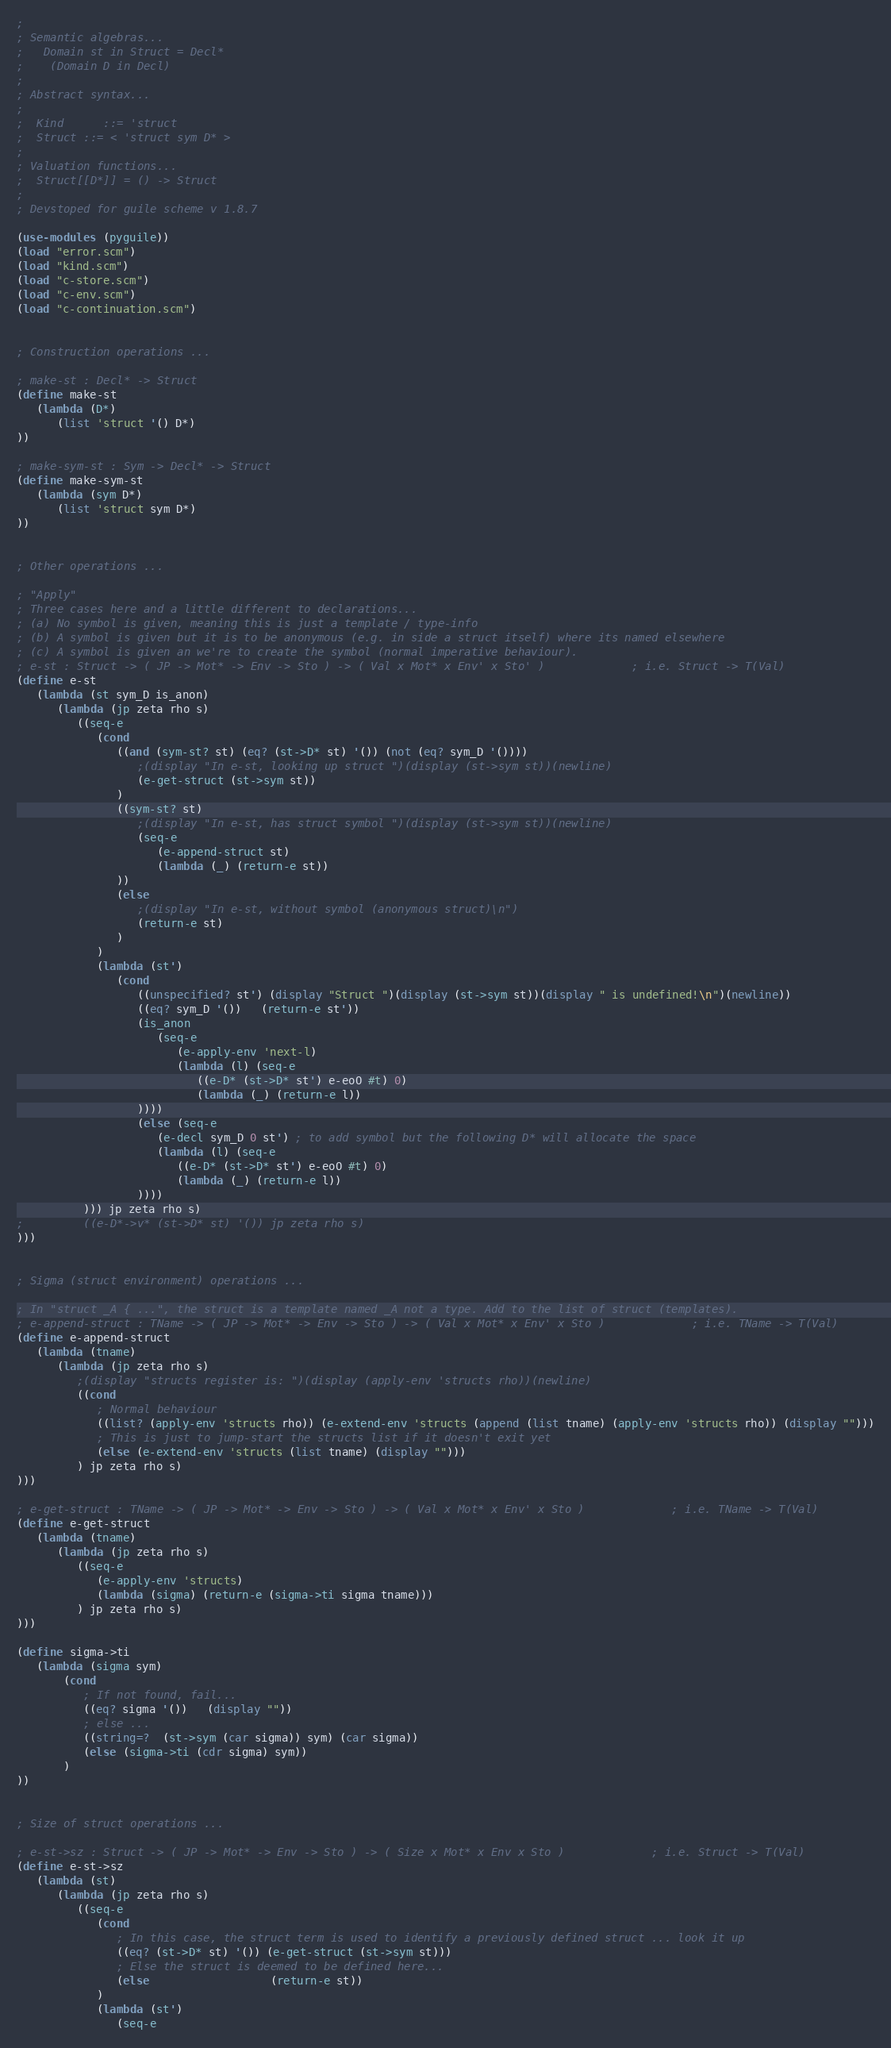Convert code to text. <code><loc_0><loc_0><loc_500><loc_500><_Scheme_>;
; Semantic algebras...
;   Domain st in Struct = Decl*
;    (Domain D in Decl)
;
; Abstract syntax...
;
;  Kind      ::= 'struct
;  Struct ::= < 'struct sym D* >
;
; Valuation functions...
;  Struct[[D*]] = () -> Struct
;
; Devstoped for guile scheme v 1.8.7

(use-modules (pyguile))
(load "error.scm")
(load "kind.scm")
(load "c-store.scm")
(load "c-env.scm")
(load "c-continuation.scm")


; Construction operations ...

; make-st : Decl* -> Struct
(define make-st
   (lambda (D*)
      (list 'struct '() D*) 
))

; make-sym-st : Sym -> Decl* -> Struct
(define make-sym-st
   (lambda (sym D*)
      (list 'struct sym D*) 
))


; Other operations ...

; "Apply"
; Three cases here and a little different to declarations...
; (a) No symbol is given, meaning this is just a template / type-info
; (b) A symbol is given but it is to be anonymous (e.g. in side a struct itself) where its named elsewhere
; (c) A symbol is given an we're to create the symbol (normal imperative behaviour).
; e-st : Struct -> ( JP -> Mot* -> Env -> Sto ) -> ( Val x Mot* x Env' x Sto' )             ; i.e. Struct -> T(Val)
(define e-st
   (lambda (st sym_D is_anon)
      (lambda (jp zeta rho s)
         ((seq-e
            (cond
               ((and (sym-st? st) (eq? (st->D* st) '()) (not (eq? sym_D '())))
                  ;(display "In e-st, looking up struct ")(display (st->sym st))(newline)
                  (e-get-struct (st->sym st))
               )
               ((sym-st? st)   
                  ;(display "In e-st, has struct symbol ")(display (st->sym st))(newline)
                  (seq-e
                     (e-append-struct st)
                     (lambda (_) (return-e st))
               ))
               (else
                  ;(display "In e-st, without symbol (anonymous struct)\n")
                  (return-e st)
               )
            )
            (lambda (st') 
               (cond
                  ((unspecified? st') (display "Struct ")(display (st->sym st))(display " is undefined!\n")(newline))
                  ((eq? sym_D '())   (return-e st'))
                  (is_anon 
                     (seq-e
                        (e-apply-env 'next-l)
                        (lambda (l) (seq-e
                           ((e-D* (st->D* st') e-eoO #t) 0)
                           (lambda (_) (return-e l))
                  ))))
                  (else (seq-e
                     (e-decl sym_D 0 st') ; to add symbol but the following D* will allocate the space
                     (lambda (l) (seq-e
                        ((e-D* (st->D* st') e-eoO #t) 0)
                        (lambda (_) (return-e l))
                  )))) 
          ))) jp zeta rho s)
;         ((e-D*->v* (st->D* st) '()) jp zeta rho s)
)))


; Sigma (struct environment) operations ...

; In "struct _A { ...", the struct is a template named _A not a type. Add to the list of struct (templates).
; e-append-struct : TName -> ( JP -> Mot* -> Env -> Sto ) -> ( Val x Mot* x Env' x Sto )             ; i.e. TName -> T(Val)
(define e-append-struct
   (lambda (tname)
      (lambda (jp zeta rho s)
         ;(display "structs register is: ")(display (apply-env 'structs rho))(newline)
         ((cond
            ; Normal behaviour
            ((list? (apply-env 'structs rho)) (e-extend-env 'structs (append (list tname) (apply-env 'structs rho)) (display "")))
            ; This is just to jump-start the structs list if it doesn't exit yet
            (else (e-extend-env 'structs (list tname) (display "")))
         ) jp zeta rho s)
)))

; e-get-struct : TName -> ( JP -> Mot* -> Env -> Sto ) -> ( Val x Mot* x Env' x Sto )             ; i.e. TName -> T(Val)
(define e-get-struct
   (lambda (tname)
      (lambda (jp zeta rho s)
         ((seq-e
            (e-apply-env 'structs)
            (lambda (sigma) (return-e (sigma->ti sigma tname)))
         ) jp zeta rho s)
)))

(define sigma->ti
   (lambda (sigma sym)
       (cond
          ; If not found, fail...
          ((eq? sigma '())   (display ""))
          ; else ...
          ((string=?  (st->sym (car sigma)) sym) (car sigma))
          (else (sigma->ti (cdr sigma) sym))
       )
))


; Size of struct operations ...

; e-st->sz : Struct -> ( JP -> Mot* -> Env -> Sto ) -> ( Size x Mot* x Env x Sto )             ; i.e. Struct -> T(Val)
(define e-st->sz
   (lambda (st)
      (lambda (jp zeta rho s)
         ((seq-e
            (cond
               ; In this case, the struct term is used to identify a previously defined struct ... look it up
               ((eq? (st->D* st) '()) (e-get-struct (st->sym st)))
               ; Else the struct is deemed to be defined here...
               (else                  (return-e st))
            )
            (lambda (st')
               (seq-e </code> 